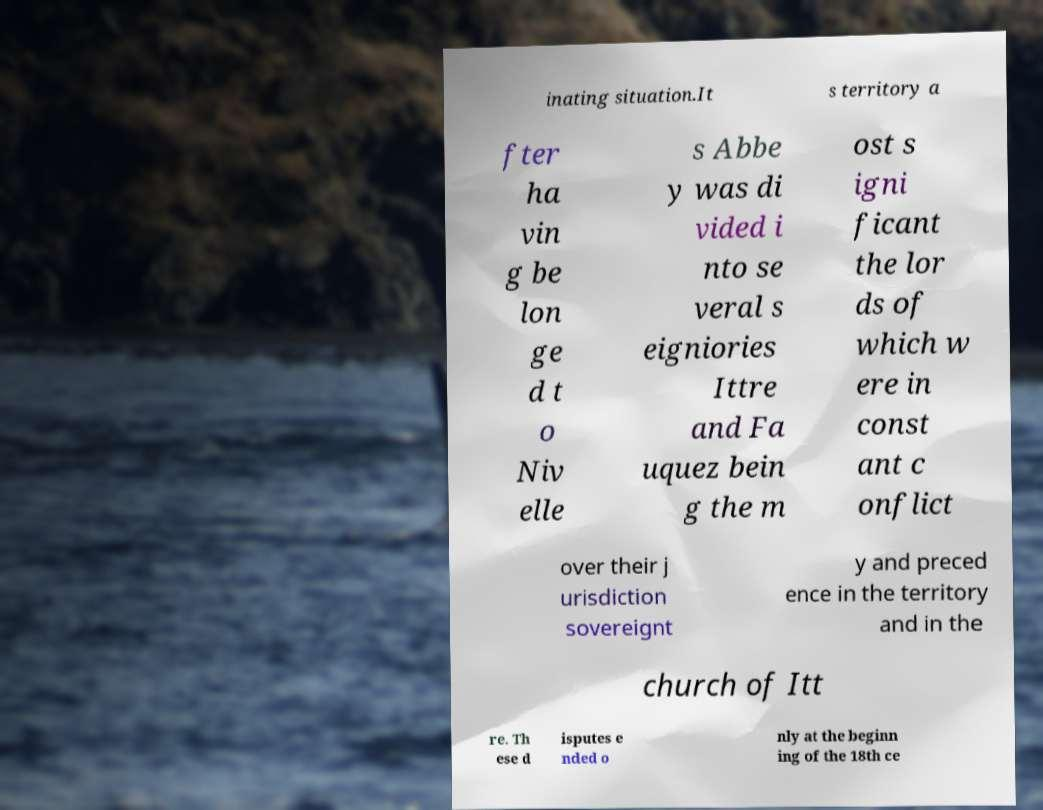Could you extract and type out the text from this image? inating situation.It s territory a fter ha vin g be lon ge d t o Niv elle s Abbe y was di vided i nto se veral s eigniories Ittre and Fa uquez bein g the m ost s igni ficant the lor ds of which w ere in const ant c onflict over their j urisdiction sovereignt y and preced ence in the territory and in the church of Itt re. Th ese d isputes e nded o nly at the beginn ing of the 18th ce 